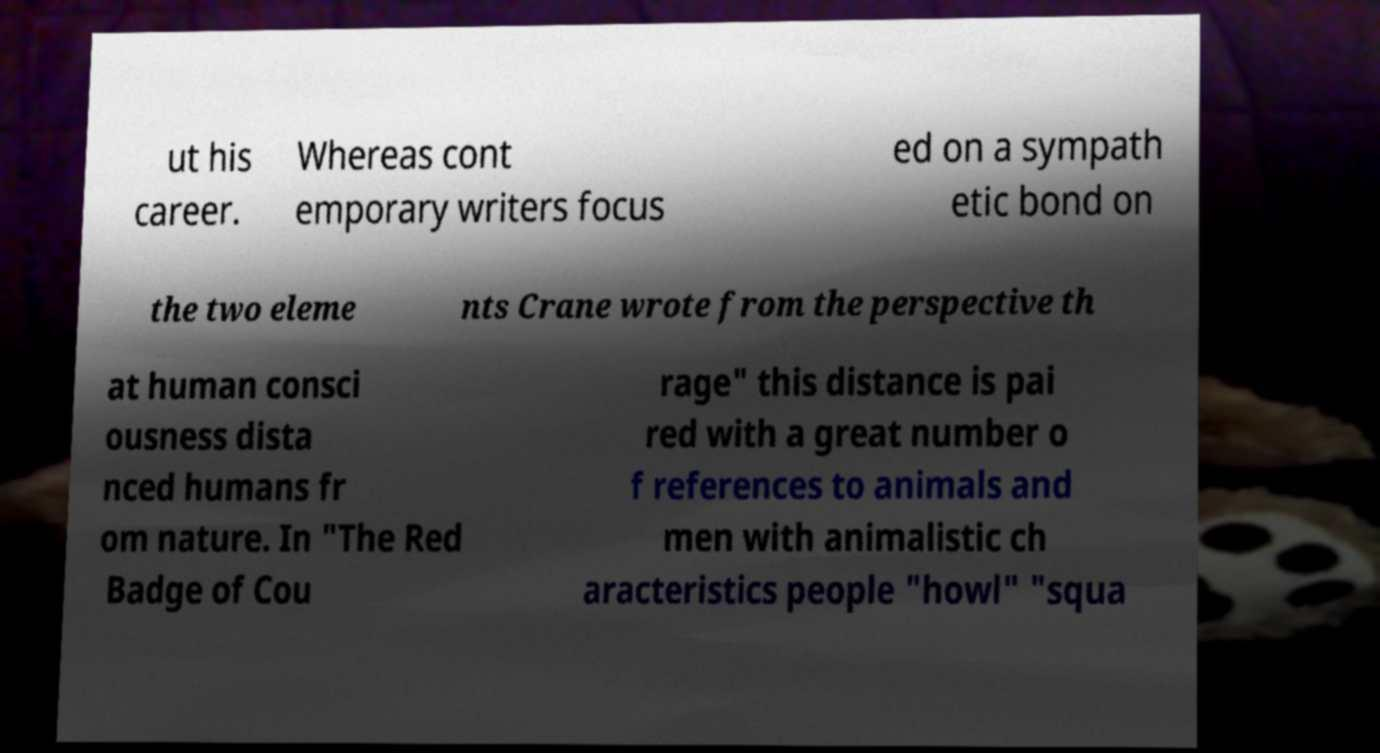For documentation purposes, I need the text within this image transcribed. Could you provide that? ut his career. Whereas cont emporary writers focus ed on a sympath etic bond on the two eleme nts Crane wrote from the perspective th at human consci ousness dista nced humans fr om nature. In "The Red Badge of Cou rage" this distance is pai red with a great number o f references to animals and men with animalistic ch aracteristics people "howl" "squa 